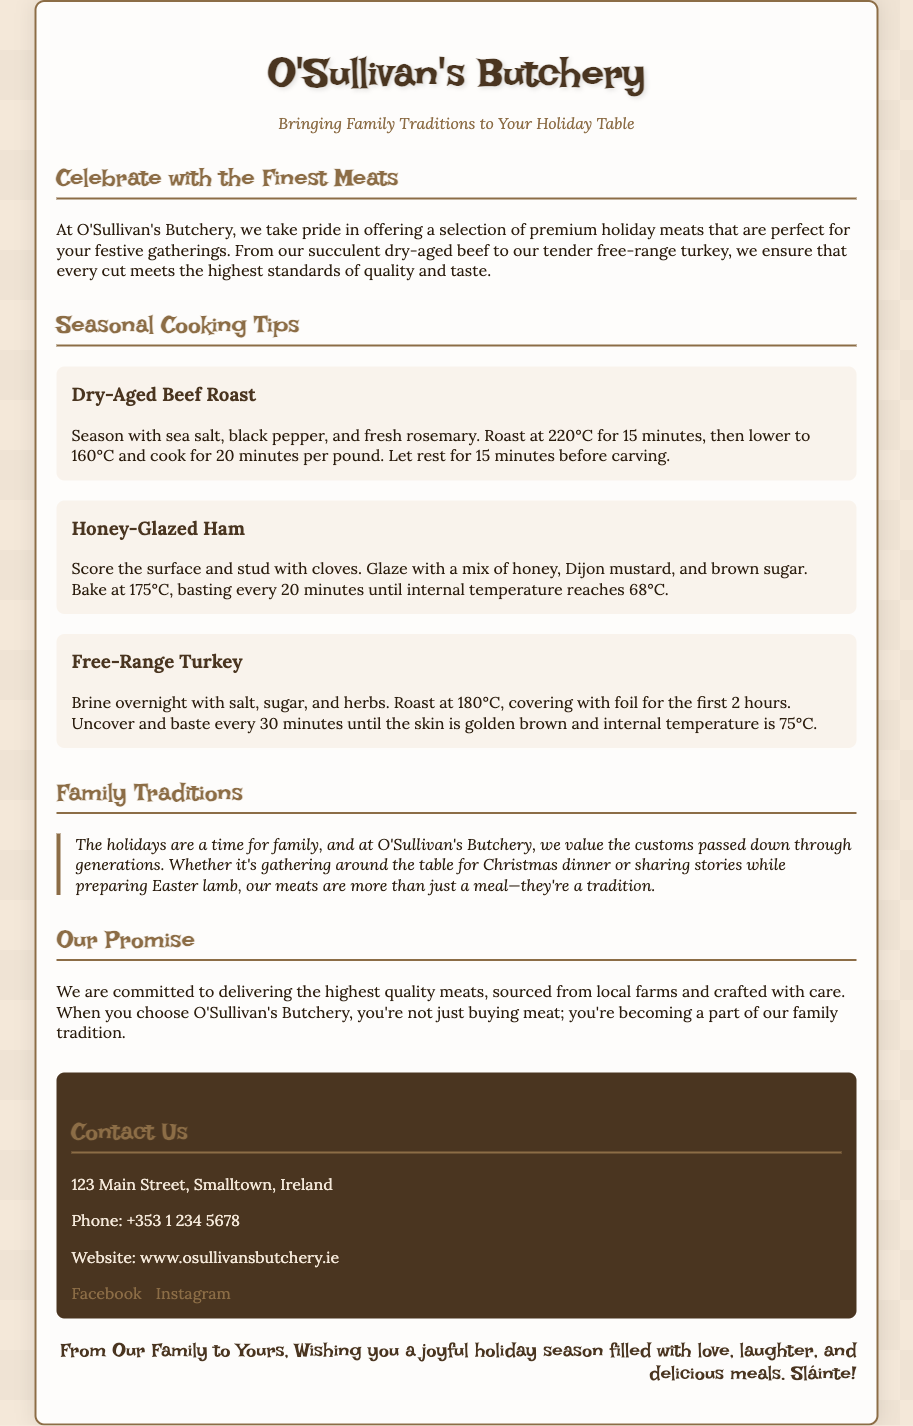what is the name of the butchery? The name of the butchery is featured prominently at the top of the document.
Answer: O'Sullivan's Butchery what type of meat is mentioned for the holiday season? The holiday meats are detailed in the document under seasonal cooking tips.
Answer: dry-aged beef, honey-glazed ham, free-range turkey how long should you roast the dry-aged beef for per pound? The document specifies the cooking time for the beef roast.
Answer: 20 minutes what is used to glaze the honey-glazed ham? The document provides a specific mixture for glazing the ham.
Answer: honey, Dijon mustard, brown sugar what internal temperature should the turkey reach? The document indicates the required internal temperature for the turkey.
Answer: 75°C in which town is O'Sullivan's Butchery located? The document includes the address details of the butchery.
Answer: Smalltown how does O'Sullivan's Butchery promise to source their meats? The butchery's commitment regarding sourcing is mentioned in the document.
Answer: from local farms what is the tagline for O'Sullivan's Butchery? The tagline can be found under the name of the butchery in the document.
Answer: Bringing Family Traditions to Your Holiday Table what cultural aspect does the butchery emphasize in their offerings? The document highlights a particular theme central to their brand.
Answer: family traditions 